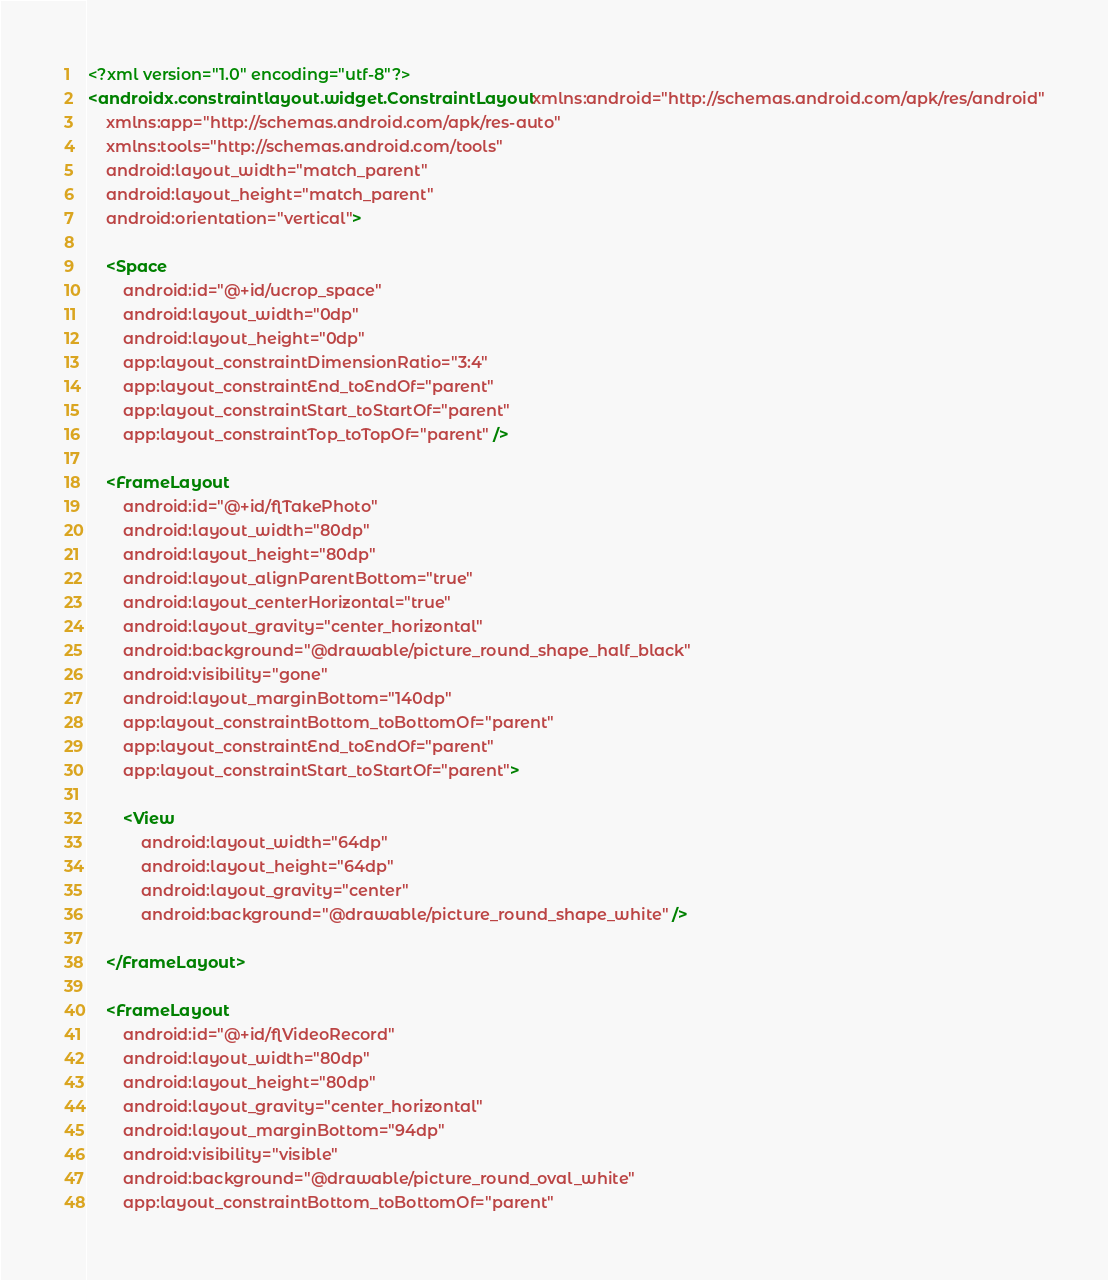Convert code to text. <code><loc_0><loc_0><loc_500><loc_500><_XML_><?xml version="1.0" encoding="utf-8"?>
<androidx.constraintlayout.widget.ConstraintLayout xmlns:android="http://schemas.android.com/apk/res/android"
    xmlns:app="http://schemas.android.com/apk/res-auto"
    xmlns:tools="http://schemas.android.com/tools"
    android:layout_width="match_parent"
    android:layout_height="match_parent"
    android:orientation="vertical">

    <Space
        android:id="@+id/ucrop_space"
        android:layout_width="0dp"
        android:layout_height="0dp"
        app:layout_constraintDimensionRatio="3:4"
        app:layout_constraintEnd_toEndOf="parent"
        app:layout_constraintStart_toStartOf="parent"
        app:layout_constraintTop_toTopOf="parent" />

    <FrameLayout
        android:id="@+id/flTakePhoto"
        android:layout_width="80dp"
        android:layout_height="80dp"
        android:layout_alignParentBottom="true"
        android:layout_centerHorizontal="true"
        android:layout_gravity="center_horizontal"
        android:background="@drawable/picture_round_shape_half_black"
        android:visibility="gone"
        android:layout_marginBottom="140dp"
        app:layout_constraintBottom_toBottomOf="parent"
        app:layout_constraintEnd_toEndOf="parent"
        app:layout_constraintStart_toStartOf="parent">

        <View
            android:layout_width="64dp"
            android:layout_height="64dp"
            android:layout_gravity="center"
            android:background="@drawable/picture_round_shape_white" />

    </FrameLayout>

    <FrameLayout
        android:id="@+id/flVideoRecord"
        android:layout_width="80dp"
        android:layout_height="80dp"
        android:layout_gravity="center_horizontal"
        android:layout_marginBottom="94dp"
        android:visibility="visible"
        android:background="@drawable/picture_round_oval_white"
        app:layout_constraintBottom_toBottomOf="parent"</code> 